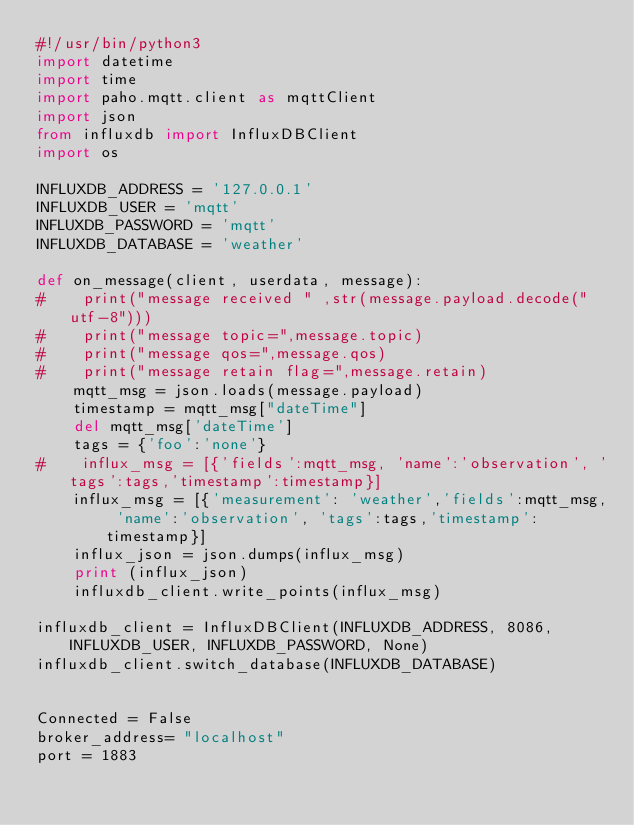Convert code to text. <code><loc_0><loc_0><loc_500><loc_500><_Python_>#!/usr/bin/python3
import datetime
import time
import paho.mqtt.client as mqttClient
import json
from influxdb import InfluxDBClient
import os

INFLUXDB_ADDRESS = '127.0.0.1'
INFLUXDB_USER = 'mqtt'
INFLUXDB_PASSWORD = 'mqtt'
INFLUXDB_DATABASE = 'weather'

def on_message(client, userdata, message):
#    print("message received " ,str(message.payload.decode("utf-8")))
#    print("message topic=",message.topic)
#    print("message qos=",message.qos)
#    print("message retain flag=",message.retain)
    mqtt_msg = json.loads(message.payload)
    timestamp = mqtt_msg["dateTime"]
    del mqtt_msg['dateTime']
    tags = {'foo':'none'}
#    influx_msg = [{'fields':mqtt_msg, 'name':'observation', 'tags':tags,'timestamp':timestamp}]
    influx_msg = [{'measurement': 'weather','fields':mqtt_msg, 'name':'observation', 'tags':tags,'timestamp':timestamp}]
    influx_json = json.dumps(influx_msg)
    print (influx_json)
    influxdb_client.write_points(influx_msg)

influxdb_client = InfluxDBClient(INFLUXDB_ADDRESS, 8086, INFLUXDB_USER, INFLUXDB_PASSWORD, None)
influxdb_client.switch_database(INFLUXDB_DATABASE)


Connected = False
broker_address= "localhost"
port = 1883</code> 